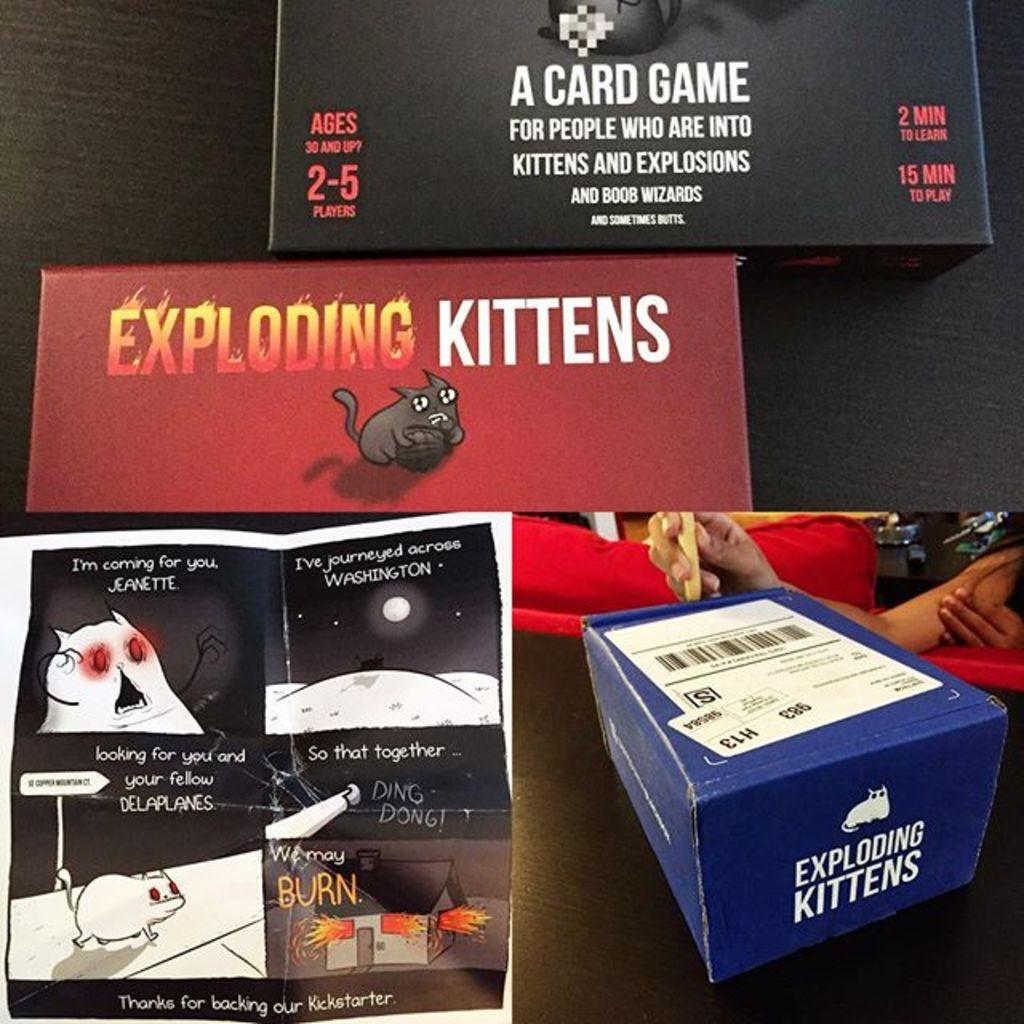<image>
Present a compact description of the photo's key features. A card game for 2 to 5 players is called "Exploding Kittens". 